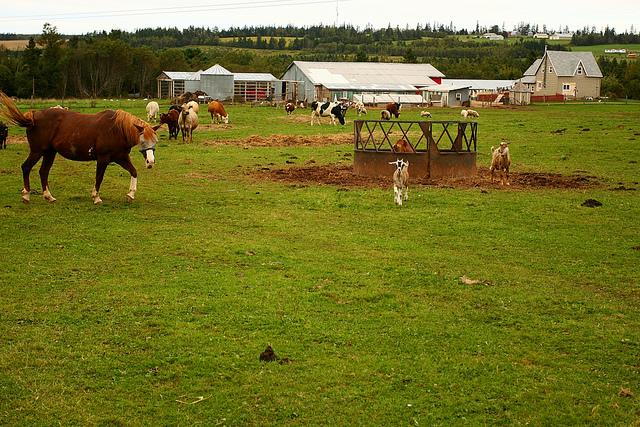How many eyes does the animal on the left have?

Choices:
A) two
B) eight
C) three
D) six two 